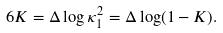Convert formula to latex. <formula><loc_0><loc_0><loc_500><loc_500>6 K = \Delta \log { \kappa _ { 1 } ^ { 2 } } = \Delta \log ( 1 - K ) .</formula> 